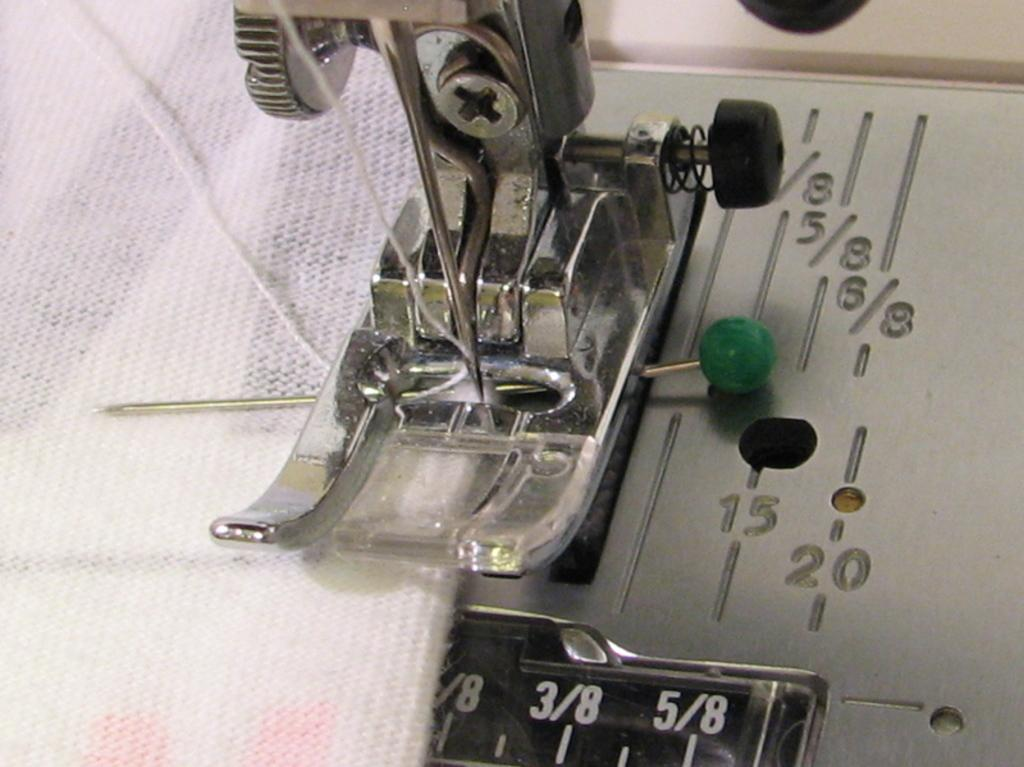What type of tool is present in the image? There is a machine tool in the image. What small object can be seen in the image? There is a pin in the image. What type of material is present in the image? There is cloth in the image. What type of markings are visible in the image? There are numbers visible in the image. What is used for sewing or stitching in the image? There is a thread in the image. How many women are depicted in the image? There are no women depicted in the image. What type of art is displayed in the image? There is no art displayed in the image. 